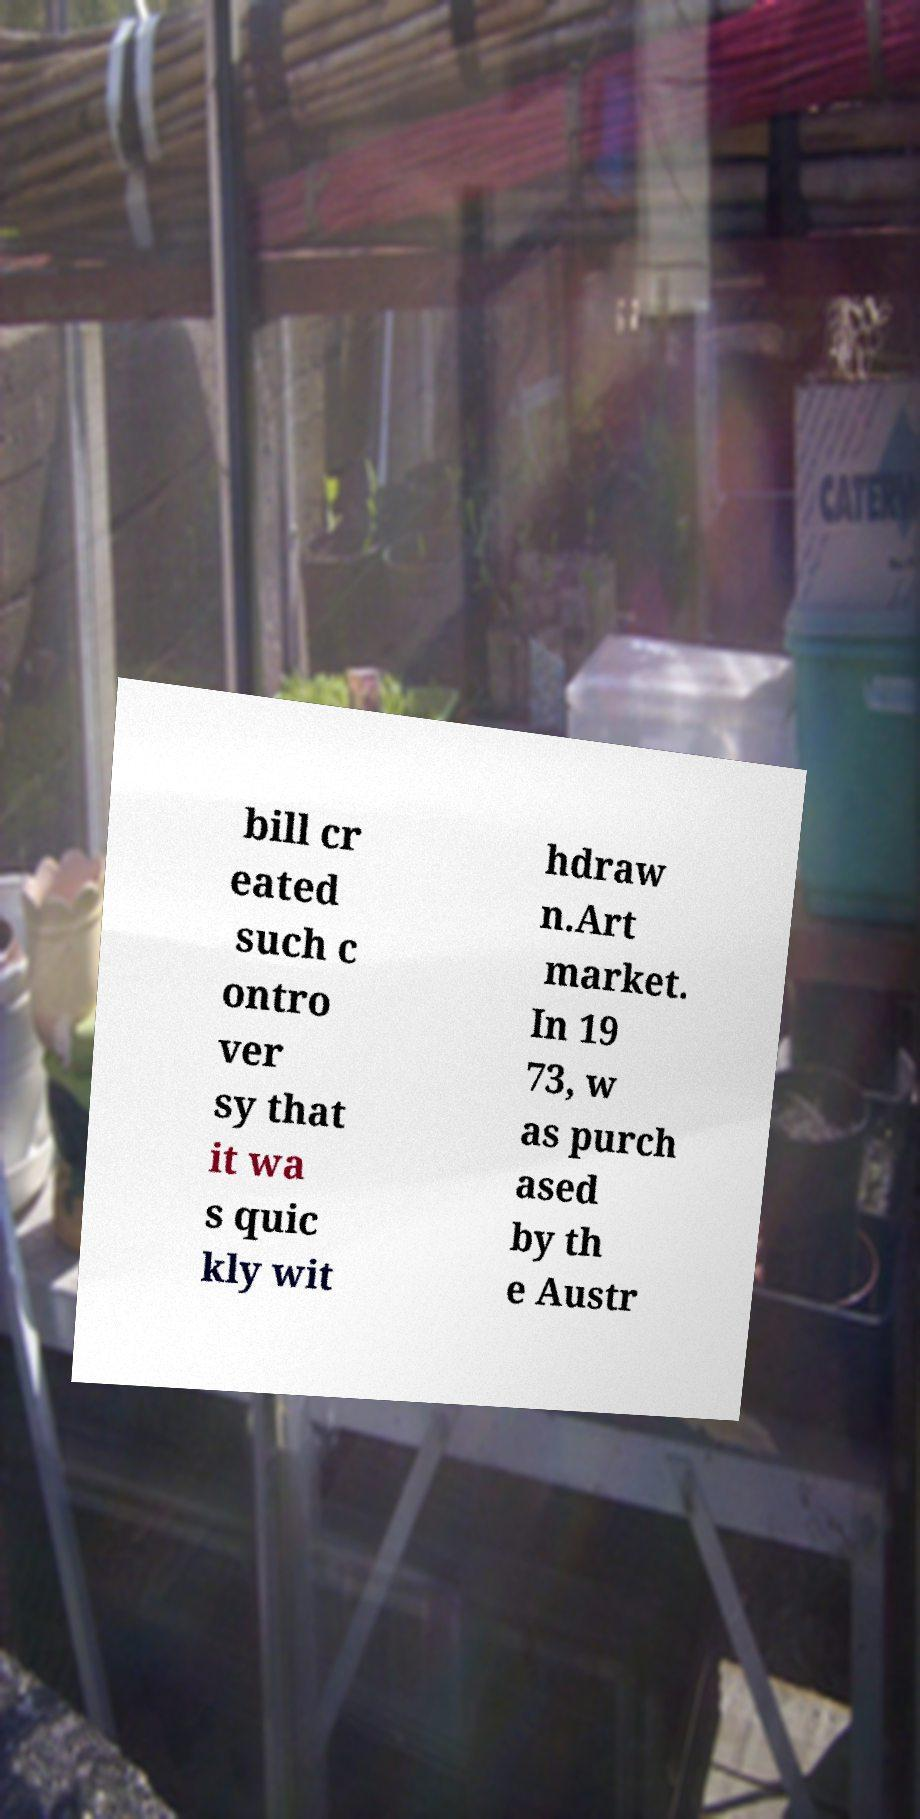I need the written content from this picture converted into text. Can you do that? bill cr eated such c ontro ver sy that it wa s quic kly wit hdraw n.Art market. In 19 73, w as purch ased by th e Austr 